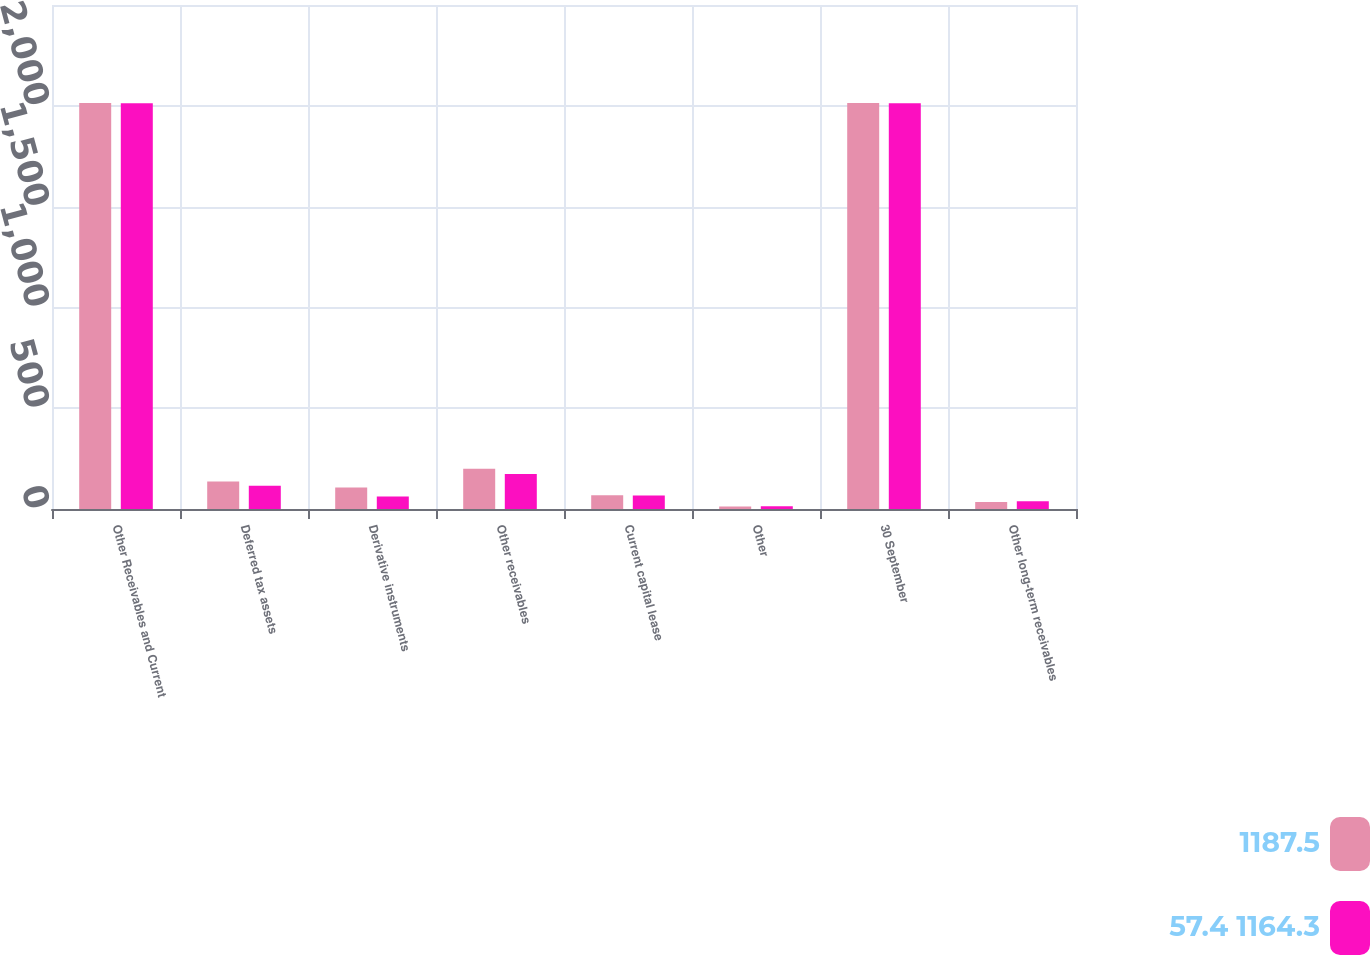<chart> <loc_0><loc_0><loc_500><loc_500><stacked_bar_chart><ecel><fcel>Other Receivables and Current<fcel>Deferred tax assets<fcel>Derivative instruments<fcel>Other receivables<fcel>Current capital lease<fcel>Other<fcel>30 September<fcel>Other long-term receivables<nl><fcel>1187.5<fcel>2014<fcel>136<fcel>106.6<fcel>200<fcel>67.8<fcel>12.6<fcel>2014<fcel>35.1<nl><fcel>57.4 1164.3<fcel>2013<fcel>115.3<fcel>61.8<fcel>174.1<fcel>67.2<fcel>14<fcel>2013<fcel>38.2<nl></chart> 